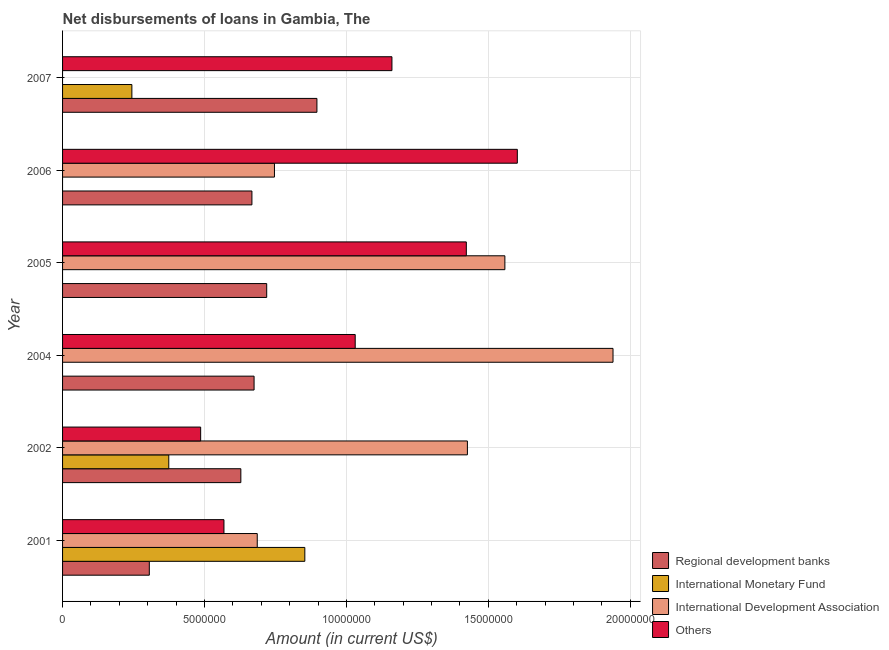How many different coloured bars are there?
Your response must be concise. 4. How many groups of bars are there?
Provide a short and direct response. 6. Are the number of bars per tick equal to the number of legend labels?
Make the answer very short. No. How many bars are there on the 5th tick from the bottom?
Your answer should be compact. 3. What is the label of the 2nd group of bars from the top?
Offer a very short reply. 2006. Across all years, what is the maximum amount of loan disimbursed by international monetary fund?
Make the answer very short. 8.54e+06. In which year was the amount of loan disimbursed by international development association maximum?
Make the answer very short. 2004. What is the total amount of loan disimbursed by international monetary fund in the graph?
Give a very brief answer. 1.47e+07. What is the difference between the amount of loan disimbursed by international development association in 2002 and that in 2004?
Offer a very short reply. -5.13e+06. What is the difference between the amount of loan disimbursed by international development association in 2002 and the amount of loan disimbursed by regional development banks in 2001?
Your response must be concise. 1.12e+07. What is the average amount of loan disimbursed by regional development banks per year?
Your answer should be compact. 6.48e+06. In the year 2004, what is the difference between the amount of loan disimbursed by regional development banks and amount of loan disimbursed by other organisations?
Provide a succinct answer. -3.56e+06. In how many years, is the amount of loan disimbursed by other organisations greater than 3000000 US$?
Your response must be concise. 6. What is the ratio of the amount of loan disimbursed by international monetary fund in 2002 to that in 2007?
Offer a terse response. 1.53. Is the amount of loan disimbursed by other organisations in 2002 less than that in 2006?
Provide a short and direct response. Yes. What is the difference between the highest and the second highest amount of loan disimbursed by regional development banks?
Your response must be concise. 1.77e+06. What is the difference between the highest and the lowest amount of loan disimbursed by regional development banks?
Offer a terse response. 5.90e+06. Is the sum of the amount of loan disimbursed by international monetary fund in 2001 and 2007 greater than the maximum amount of loan disimbursed by regional development banks across all years?
Your response must be concise. Yes. Are all the bars in the graph horizontal?
Ensure brevity in your answer.  Yes. How many years are there in the graph?
Your response must be concise. 6. What is the difference between two consecutive major ticks on the X-axis?
Your response must be concise. 5.00e+06. Does the graph contain any zero values?
Keep it short and to the point. Yes. Where does the legend appear in the graph?
Make the answer very short. Bottom right. How are the legend labels stacked?
Offer a very short reply. Vertical. What is the title of the graph?
Your answer should be compact. Net disbursements of loans in Gambia, The. Does "International Development Association" appear as one of the legend labels in the graph?
Ensure brevity in your answer.  Yes. What is the label or title of the Y-axis?
Provide a succinct answer. Year. What is the Amount (in current US$) in Regional development banks in 2001?
Offer a very short reply. 3.06e+06. What is the Amount (in current US$) in International Monetary Fund in 2001?
Provide a succinct answer. 8.54e+06. What is the Amount (in current US$) in International Development Association in 2001?
Your answer should be very brief. 6.86e+06. What is the Amount (in current US$) of Others in 2001?
Give a very brief answer. 5.69e+06. What is the Amount (in current US$) in Regional development banks in 2002?
Keep it short and to the point. 6.28e+06. What is the Amount (in current US$) of International Monetary Fund in 2002?
Offer a terse response. 3.74e+06. What is the Amount (in current US$) in International Development Association in 2002?
Give a very brief answer. 1.43e+07. What is the Amount (in current US$) of Others in 2002?
Your response must be concise. 4.86e+06. What is the Amount (in current US$) of Regional development banks in 2004?
Your answer should be very brief. 6.75e+06. What is the Amount (in current US$) in International Monetary Fund in 2004?
Provide a short and direct response. 0. What is the Amount (in current US$) of International Development Association in 2004?
Your answer should be compact. 1.94e+07. What is the Amount (in current US$) in Others in 2004?
Offer a terse response. 1.03e+07. What is the Amount (in current US$) in Regional development banks in 2005?
Give a very brief answer. 7.19e+06. What is the Amount (in current US$) in International Monetary Fund in 2005?
Your answer should be very brief. 0. What is the Amount (in current US$) of International Development Association in 2005?
Keep it short and to the point. 1.56e+07. What is the Amount (in current US$) of Others in 2005?
Your response must be concise. 1.42e+07. What is the Amount (in current US$) of Regional development banks in 2006?
Your answer should be very brief. 6.67e+06. What is the Amount (in current US$) in International Monetary Fund in 2006?
Make the answer very short. 0. What is the Amount (in current US$) in International Development Association in 2006?
Offer a very short reply. 7.46e+06. What is the Amount (in current US$) of Others in 2006?
Provide a succinct answer. 1.60e+07. What is the Amount (in current US$) of Regional development banks in 2007?
Your answer should be compact. 8.96e+06. What is the Amount (in current US$) of International Monetary Fund in 2007?
Make the answer very short. 2.44e+06. What is the Amount (in current US$) of Others in 2007?
Your answer should be very brief. 1.16e+07. Across all years, what is the maximum Amount (in current US$) in Regional development banks?
Your answer should be compact. 8.96e+06. Across all years, what is the maximum Amount (in current US$) of International Monetary Fund?
Offer a terse response. 8.54e+06. Across all years, what is the maximum Amount (in current US$) in International Development Association?
Your answer should be very brief. 1.94e+07. Across all years, what is the maximum Amount (in current US$) of Others?
Your answer should be very brief. 1.60e+07. Across all years, what is the minimum Amount (in current US$) of Regional development banks?
Offer a very short reply. 3.06e+06. Across all years, what is the minimum Amount (in current US$) of Others?
Ensure brevity in your answer.  4.86e+06. What is the total Amount (in current US$) of Regional development banks in the graph?
Provide a succinct answer. 3.89e+07. What is the total Amount (in current US$) in International Monetary Fund in the graph?
Ensure brevity in your answer.  1.47e+07. What is the total Amount (in current US$) of International Development Association in the graph?
Provide a succinct answer. 6.36e+07. What is the total Amount (in current US$) of Others in the graph?
Provide a short and direct response. 6.27e+07. What is the difference between the Amount (in current US$) in Regional development banks in 2001 and that in 2002?
Your response must be concise. -3.22e+06. What is the difference between the Amount (in current US$) in International Monetary Fund in 2001 and that in 2002?
Offer a terse response. 4.79e+06. What is the difference between the Amount (in current US$) in International Development Association in 2001 and that in 2002?
Ensure brevity in your answer.  -7.40e+06. What is the difference between the Amount (in current US$) of Others in 2001 and that in 2002?
Offer a very short reply. 8.21e+05. What is the difference between the Amount (in current US$) of Regional development banks in 2001 and that in 2004?
Ensure brevity in your answer.  -3.69e+06. What is the difference between the Amount (in current US$) of International Development Association in 2001 and that in 2004?
Provide a succinct answer. -1.25e+07. What is the difference between the Amount (in current US$) of Others in 2001 and that in 2004?
Your answer should be very brief. -4.62e+06. What is the difference between the Amount (in current US$) of Regional development banks in 2001 and that in 2005?
Offer a terse response. -4.14e+06. What is the difference between the Amount (in current US$) in International Development Association in 2001 and that in 2005?
Provide a succinct answer. -8.72e+06. What is the difference between the Amount (in current US$) in Others in 2001 and that in 2005?
Your answer should be compact. -8.54e+06. What is the difference between the Amount (in current US$) in Regional development banks in 2001 and that in 2006?
Offer a very short reply. -3.62e+06. What is the difference between the Amount (in current US$) of International Development Association in 2001 and that in 2006?
Offer a terse response. -6.06e+05. What is the difference between the Amount (in current US$) of Others in 2001 and that in 2006?
Ensure brevity in your answer.  -1.03e+07. What is the difference between the Amount (in current US$) of Regional development banks in 2001 and that in 2007?
Provide a short and direct response. -5.90e+06. What is the difference between the Amount (in current US$) in International Monetary Fund in 2001 and that in 2007?
Offer a very short reply. 6.09e+06. What is the difference between the Amount (in current US$) in Others in 2001 and that in 2007?
Offer a terse response. -5.92e+06. What is the difference between the Amount (in current US$) in Regional development banks in 2002 and that in 2004?
Provide a short and direct response. -4.66e+05. What is the difference between the Amount (in current US$) in International Development Association in 2002 and that in 2004?
Offer a terse response. -5.13e+06. What is the difference between the Amount (in current US$) of Others in 2002 and that in 2004?
Your response must be concise. -5.44e+06. What is the difference between the Amount (in current US$) of Regional development banks in 2002 and that in 2005?
Make the answer very short. -9.11e+05. What is the difference between the Amount (in current US$) in International Development Association in 2002 and that in 2005?
Your answer should be compact. -1.32e+06. What is the difference between the Amount (in current US$) of Others in 2002 and that in 2005?
Offer a very short reply. -9.36e+06. What is the difference between the Amount (in current US$) in Regional development banks in 2002 and that in 2006?
Provide a succinct answer. -3.90e+05. What is the difference between the Amount (in current US$) of International Development Association in 2002 and that in 2006?
Provide a short and direct response. 6.80e+06. What is the difference between the Amount (in current US$) of Others in 2002 and that in 2006?
Your response must be concise. -1.12e+07. What is the difference between the Amount (in current US$) of Regional development banks in 2002 and that in 2007?
Offer a very short reply. -2.68e+06. What is the difference between the Amount (in current US$) of International Monetary Fund in 2002 and that in 2007?
Offer a terse response. 1.30e+06. What is the difference between the Amount (in current US$) of Others in 2002 and that in 2007?
Make the answer very short. -6.74e+06. What is the difference between the Amount (in current US$) of Regional development banks in 2004 and that in 2005?
Your answer should be very brief. -4.45e+05. What is the difference between the Amount (in current US$) in International Development Association in 2004 and that in 2005?
Your answer should be very brief. 3.81e+06. What is the difference between the Amount (in current US$) in Others in 2004 and that in 2005?
Make the answer very short. -3.92e+06. What is the difference between the Amount (in current US$) of Regional development banks in 2004 and that in 2006?
Provide a short and direct response. 7.60e+04. What is the difference between the Amount (in current US$) in International Development Association in 2004 and that in 2006?
Offer a terse response. 1.19e+07. What is the difference between the Amount (in current US$) in Others in 2004 and that in 2006?
Offer a very short reply. -5.71e+06. What is the difference between the Amount (in current US$) in Regional development banks in 2004 and that in 2007?
Provide a short and direct response. -2.21e+06. What is the difference between the Amount (in current US$) of Others in 2004 and that in 2007?
Your answer should be compact. -1.29e+06. What is the difference between the Amount (in current US$) in Regional development banks in 2005 and that in 2006?
Offer a terse response. 5.21e+05. What is the difference between the Amount (in current US$) in International Development Association in 2005 and that in 2006?
Ensure brevity in your answer.  8.12e+06. What is the difference between the Amount (in current US$) in Others in 2005 and that in 2006?
Your answer should be compact. -1.80e+06. What is the difference between the Amount (in current US$) in Regional development banks in 2005 and that in 2007?
Make the answer very short. -1.77e+06. What is the difference between the Amount (in current US$) in Others in 2005 and that in 2007?
Offer a terse response. 2.62e+06. What is the difference between the Amount (in current US$) of Regional development banks in 2006 and that in 2007?
Make the answer very short. -2.29e+06. What is the difference between the Amount (in current US$) in Others in 2006 and that in 2007?
Your answer should be compact. 4.42e+06. What is the difference between the Amount (in current US$) in Regional development banks in 2001 and the Amount (in current US$) in International Monetary Fund in 2002?
Give a very brief answer. -6.86e+05. What is the difference between the Amount (in current US$) of Regional development banks in 2001 and the Amount (in current US$) of International Development Association in 2002?
Your response must be concise. -1.12e+07. What is the difference between the Amount (in current US$) in Regional development banks in 2001 and the Amount (in current US$) in Others in 2002?
Make the answer very short. -1.81e+06. What is the difference between the Amount (in current US$) in International Monetary Fund in 2001 and the Amount (in current US$) in International Development Association in 2002?
Your answer should be compact. -5.73e+06. What is the difference between the Amount (in current US$) of International Monetary Fund in 2001 and the Amount (in current US$) of Others in 2002?
Offer a very short reply. 3.67e+06. What is the difference between the Amount (in current US$) of International Development Association in 2001 and the Amount (in current US$) of Others in 2002?
Ensure brevity in your answer.  1.99e+06. What is the difference between the Amount (in current US$) of Regional development banks in 2001 and the Amount (in current US$) of International Development Association in 2004?
Ensure brevity in your answer.  -1.63e+07. What is the difference between the Amount (in current US$) of Regional development banks in 2001 and the Amount (in current US$) of Others in 2004?
Your response must be concise. -7.25e+06. What is the difference between the Amount (in current US$) of International Monetary Fund in 2001 and the Amount (in current US$) of International Development Association in 2004?
Offer a very short reply. -1.09e+07. What is the difference between the Amount (in current US$) of International Monetary Fund in 2001 and the Amount (in current US$) of Others in 2004?
Provide a short and direct response. -1.78e+06. What is the difference between the Amount (in current US$) in International Development Association in 2001 and the Amount (in current US$) in Others in 2004?
Offer a very short reply. -3.45e+06. What is the difference between the Amount (in current US$) in Regional development banks in 2001 and the Amount (in current US$) in International Development Association in 2005?
Provide a succinct answer. -1.25e+07. What is the difference between the Amount (in current US$) of Regional development banks in 2001 and the Amount (in current US$) of Others in 2005?
Provide a succinct answer. -1.12e+07. What is the difference between the Amount (in current US$) of International Monetary Fund in 2001 and the Amount (in current US$) of International Development Association in 2005?
Your response must be concise. -7.05e+06. What is the difference between the Amount (in current US$) of International Monetary Fund in 2001 and the Amount (in current US$) of Others in 2005?
Provide a succinct answer. -5.69e+06. What is the difference between the Amount (in current US$) of International Development Association in 2001 and the Amount (in current US$) of Others in 2005?
Provide a short and direct response. -7.37e+06. What is the difference between the Amount (in current US$) of Regional development banks in 2001 and the Amount (in current US$) of International Development Association in 2006?
Provide a short and direct response. -4.41e+06. What is the difference between the Amount (in current US$) of Regional development banks in 2001 and the Amount (in current US$) of Others in 2006?
Provide a succinct answer. -1.30e+07. What is the difference between the Amount (in current US$) in International Monetary Fund in 2001 and the Amount (in current US$) in International Development Association in 2006?
Offer a terse response. 1.07e+06. What is the difference between the Amount (in current US$) of International Monetary Fund in 2001 and the Amount (in current US$) of Others in 2006?
Keep it short and to the point. -7.49e+06. What is the difference between the Amount (in current US$) of International Development Association in 2001 and the Amount (in current US$) of Others in 2006?
Your response must be concise. -9.16e+06. What is the difference between the Amount (in current US$) of Regional development banks in 2001 and the Amount (in current US$) of International Monetary Fund in 2007?
Offer a very short reply. 6.14e+05. What is the difference between the Amount (in current US$) of Regional development banks in 2001 and the Amount (in current US$) of Others in 2007?
Provide a succinct answer. -8.55e+06. What is the difference between the Amount (in current US$) of International Monetary Fund in 2001 and the Amount (in current US$) of Others in 2007?
Give a very brief answer. -3.07e+06. What is the difference between the Amount (in current US$) in International Development Association in 2001 and the Amount (in current US$) in Others in 2007?
Your response must be concise. -4.74e+06. What is the difference between the Amount (in current US$) of Regional development banks in 2002 and the Amount (in current US$) of International Development Association in 2004?
Provide a succinct answer. -1.31e+07. What is the difference between the Amount (in current US$) of Regional development banks in 2002 and the Amount (in current US$) of Others in 2004?
Provide a succinct answer. -4.03e+06. What is the difference between the Amount (in current US$) in International Monetary Fund in 2002 and the Amount (in current US$) in International Development Association in 2004?
Your answer should be compact. -1.57e+07. What is the difference between the Amount (in current US$) in International Monetary Fund in 2002 and the Amount (in current US$) in Others in 2004?
Ensure brevity in your answer.  -6.57e+06. What is the difference between the Amount (in current US$) in International Development Association in 2002 and the Amount (in current US$) in Others in 2004?
Keep it short and to the point. 3.95e+06. What is the difference between the Amount (in current US$) of Regional development banks in 2002 and the Amount (in current US$) of International Development Association in 2005?
Offer a very short reply. -9.30e+06. What is the difference between the Amount (in current US$) of Regional development banks in 2002 and the Amount (in current US$) of Others in 2005?
Ensure brevity in your answer.  -7.94e+06. What is the difference between the Amount (in current US$) of International Monetary Fund in 2002 and the Amount (in current US$) of International Development Association in 2005?
Your answer should be compact. -1.18e+07. What is the difference between the Amount (in current US$) in International Monetary Fund in 2002 and the Amount (in current US$) in Others in 2005?
Offer a terse response. -1.05e+07. What is the difference between the Amount (in current US$) in International Development Association in 2002 and the Amount (in current US$) in Others in 2005?
Offer a terse response. 3.80e+04. What is the difference between the Amount (in current US$) in Regional development banks in 2002 and the Amount (in current US$) in International Development Association in 2006?
Ensure brevity in your answer.  -1.18e+06. What is the difference between the Amount (in current US$) of Regional development banks in 2002 and the Amount (in current US$) of Others in 2006?
Provide a succinct answer. -9.74e+06. What is the difference between the Amount (in current US$) in International Monetary Fund in 2002 and the Amount (in current US$) in International Development Association in 2006?
Provide a short and direct response. -3.72e+06. What is the difference between the Amount (in current US$) in International Monetary Fund in 2002 and the Amount (in current US$) in Others in 2006?
Offer a very short reply. -1.23e+07. What is the difference between the Amount (in current US$) of International Development Association in 2002 and the Amount (in current US$) of Others in 2006?
Make the answer very short. -1.76e+06. What is the difference between the Amount (in current US$) in Regional development banks in 2002 and the Amount (in current US$) in International Monetary Fund in 2007?
Your answer should be compact. 3.84e+06. What is the difference between the Amount (in current US$) of Regional development banks in 2002 and the Amount (in current US$) of Others in 2007?
Offer a terse response. -5.32e+06. What is the difference between the Amount (in current US$) of International Monetary Fund in 2002 and the Amount (in current US$) of Others in 2007?
Keep it short and to the point. -7.86e+06. What is the difference between the Amount (in current US$) in International Development Association in 2002 and the Amount (in current US$) in Others in 2007?
Your answer should be compact. 2.66e+06. What is the difference between the Amount (in current US$) in Regional development banks in 2004 and the Amount (in current US$) in International Development Association in 2005?
Give a very brief answer. -8.84e+06. What is the difference between the Amount (in current US$) in Regional development banks in 2004 and the Amount (in current US$) in Others in 2005?
Your response must be concise. -7.48e+06. What is the difference between the Amount (in current US$) in International Development Association in 2004 and the Amount (in current US$) in Others in 2005?
Your answer should be very brief. 5.17e+06. What is the difference between the Amount (in current US$) in Regional development banks in 2004 and the Amount (in current US$) in International Development Association in 2006?
Provide a short and direct response. -7.18e+05. What is the difference between the Amount (in current US$) of Regional development banks in 2004 and the Amount (in current US$) of Others in 2006?
Provide a short and direct response. -9.28e+06. What is the difference between the Amount (in current US$) in International Development Association in 2004 and the Amount (in current US$) in Others in 2006?
Offer a terse response. 3.37e+06. What is the difference between the Amount (in current US$) of Regional development banks in 2004 and the Amount (in current US$) of International Monetary Fund in 2007?
Your answer should be compact. 4.30e+06. What is the difference between the Amount (in current US$) in Regional development banks in 2004 and the Amount (in current US$) in Others in 2007?
Keep it short and to the point. -4.86e+06. What is the difference between the Amount (in current US$) of International Development Association in 2004 and the Amount (in current US$) of Others in 2007?
Your answer should be very brief. 7.79e+06. What is the difference between the Amount (in current US$) of Regional development banks in 2005 and the Amount (in current US$) of International Development Association in 2006?
Offer a terse response. -2.73e+05. What is the difference between the Amount (in current US$) in Regional development banks in 2005 and the Amount (in current US$) in Others in 2006?
Provide a short and direct response. -8.83e+06. What is the difference between the Amount (in current US$) in International Development Association in 2005 and the Amount (in current US$) in Others in 2006?
Make the answer very short. -4.39e+05. What is the difference between the Amount (in current US$) of Regional development banks in 2005 and the Amount (in current US$) of International Monetary Fund in 2007?
Give a very brief answer. 4.75e+06. What is the difference between the Amount (in current US$) in Regional development banks in 2005 and the Amount (in current US$) in Others in 2007?
Your response must be concise. -4.41e+06. What is the difference between the Amount (in current US$) of International Development Association in 2005 and the Amount (in current US$) of Others in 2007?
Make the answer very short. 3.98e+06. What is the difference between the Amount (in current US$) in Regional development banks in 2006 and the Amount (in current US$) in International Monetary Fund in 2007?
Offer a terse response. 4.23e+06. What is the difference between the Amount (in current US$) in Regional development banks in 2006 and the Amount (in current US$) in Others in 2007?
Provide a succinct answer. -4.93e+06. What is the difference between the Amount (in current US$) of International Development Association in 2006 and the Amount (in current US$) of Others in 2007?
Provide a succinct answer. -4.14e+06. What is the average Amount (in current US$) in Regional development banks per year?
Your answer should be very brief. 6.48e+06. What is the average Amount (in current US$) of International Monetary Fund per year?
Provide a short and direct response. 2.45e+06. What is the average Amount (in current US$) of International Development Association per year?
Your response must be concise. 1.06e+07. What is the average Amount (in current US$) in Others per year?
Your answer should be compact. 1.05e+07. In the year 2001, what is the difference between the Amount (in current US$) in Regional development banks and Amount (in current US$) in International Monetary Fund?
Offer a very short reply. -5.48e+06. In the year 2001, what is the difference between the Amount (in current US$) in Regional development banks and Amount (in current US$) in International Development Association?
Your answer should be very brief. -3.80e+06. In the year 2001, what is the difference between the Amount (in current US$) of Regional development banks and Amount (in current US$) of Others?
Give a very brief answer. -2.63e+06. In the year 2001, what is the difference between the Amount (in current US$) in International Monetary Fund and Amount (in current US$) in International Development Association?
Provide a short and direct response. 1.68e+06. In the year 2001, what is the difference between the Amount (in current US$) in International Monetary Fund and Amount (in current US$) in Others?
Offer a terse response. 2.85e+06. In the year 2001, what is the difference between the Amount (in current US$) of International Development Association and Amount (in current US$) of Others?
Your answer should be very brief. 1.17e+06. In the year 2002, what is the difference between the Amount (in current US$) in Regional development banks and Amount (in current US$) in International Monetary Fund?
Make the answer very short. 2.54e+06. In the year 2002, what is the difference between the Amount (in current US$) of Regional development banks and Amount (in current US$) of International Development Association?
Your answer should be compact. -7.98e+06. In the year 2002, what is the difference between the Amount (in current US$) in Regional development banks and Amount (in current US$) in Others?
Provide a short and direct response. 1.42e+06. In the year 2002, what is the difference between the Amount (in current US$) in International Monetary Fund and Amount (in current US$) in International Development Association?
Provide a succinct answer. -1.05e+07. In the year 2002, what is the difference between the Amount (in current US$) in International Monetary Fund and Amount (in current US$) in Others?
Ensure brevity in your answer.  -1.12e+06. In the year 2002, what is the difference between the Amount (in current US$) of International Development Association and Amount (in current US$) of Others?
Ensure brevity in your answer.  9.40e+06. In the year 2004, what is the difference between the Amount (in current US$) in Regional development banks and Amount (in current US$) in International Development Association?
Provide a succinct answer. -1.26e+07. In the year 2004, what is the difference between the Amount (in current US$) in Regional development banks and Amount (in current US$) in Others?
Your response must be concise. -3.56e+06. In the year 2004, what is the difference between the Amount (in current US$) in International Development Association and Amount (in current US$) in Others?
Provide a short and direct response. 9.08e+06. In the year 2005, what is the difference between the Amount (in current US$) in Regional development banks and Amount (in current US$) in International Development Association?
Offer a terse response. -8.39e+06. In the year 2005, what is the difference between the Amount (in current US$) of Regional development banks and Amount (in current US$) of Others?
Your answer should be compact. -7.03e+06. In the year 2005, what is the difference between the Amount (in current US$) of International Development Association and Amount (in current US$) of Others?
Provide a succinct answer. 1.36e+06. In the year 2006, what is the difference between the Amount (in current US$) of Regional development banks and Amount (in current US$) of International Development Association?
Offer a terse response. -7.94e+05. In the year 2006, what is the difference between the Amount (in current US$) in Regional development banks and Amount (in current US$) in Others?
Offer a terse response. -9.35e+06. In the year 2006, what is the difference between the Amount (in current US$) in International Development Association and Amount (in current US$) in Others?
Make the answer very short. -8.56e+06. In the year 2007, what is the difference between the Amount (in current US$) in Regional development banks and Amount (in current US$) in International Monetary Fund?
Give a very brief answer. 6.52e+06. In the year 2007, what is the difference between the Amount (in current US$) of Regional development banks and Amount (in current US$) of Others?
Give a very brief answer. -2.64e+06. In the year 2007, what is the difference between the Amount (in current US$) in International Monetary Fund and Amount (in current US$) in Others?
Offer a terse response. -9.16e+06. What is the ratio of the Amount (in current US$) in Regional development banks in 2001 to that in 2002?
Your response must be concise. 0.49. What is the ratio of the Amount (in current US$) in International Monetary Fund in 2001 to that in 2002?
Make the answer very short. 2.28. What is the ratio of the Amount (in current US$) in International Development Association in 2001 to that in 2002?
Provide a short and direct response. 0.48. What is the ratio of the Amount (in current US$) of Others in 2001 to that in 2002?
Your response must be concise. 1.17. What is the ratio of the Amount (in current US$) in Regional development banks in 2001 to that in 2004?
Make the answer very short. 0.45. What is the ratio of the Amount (in current US$) of International Development Association in 2001 to that in 2004?
Offer a terse response. 0.35. What is the ratio of the Amount (in current US$) in Others in 2001 to that in 2004?
Ensure brevity in your answer.  0.55. What is the ratio of the Amount (in current US$) in Regional development banks in 2001 to that in 2005?
Provide a succinct answer. 0.42. What is the ratio of the Amount (in current US$) in International Development Association in 2001 to that in 2005?
Your response must be concise. 0.44. What is the ratio of the Amount (in current US$) of Others in 2001 to that in 2005?
Give a very brief answer. 0.4. What is the ratio of the Amount (in current US$) in Regional development banks in 2001 to that in 2006?
Give a very brief answer. 0.46. What is the ratio of the Amount (in current US$) of International Development Association in 2001 to that in 2006?
Offer a terse response. 0.92. What is the ratio of the Amount (in current US$) of Others in 2001 to that in 2006?
Your answer should be compact. 0.35. What is the ratio of the Amount (in current US$) of Regional development banks in 2001 to that in 2007?
Your answer should be compact. 0.34. What is the ratio of the Amount (in current US$) in International Monetary Fund in 2001 to that in 2007?
Give a very brief answer. 3.5. What is the ratio of the Amount (in current US$) of Others in 2001 to that in 2007?
Your response must be concise. 0.49. What is the ratio of the Amount (in current US$) in Regional development banks in 2002 to that in 2004?
Offer a terse response. 0.93. What is the ratio of the Amount (in current US$) of International Development Association in 2002 to that in 2004?
Offer a terse response. 0.74. What is the ratio of the Amount (in current US$) of Others in 2002 to that in 2004?
Your answer should be compact. 0.47. What is the ratio of the Amount (in current US$) of Regional development banks in 2002 to that in 2005?
Ensure brevity in your answer.  0.87. What is the ratio of the Amount (in current US$) of International Development Association in 2002 to that in 2005?
Your response must be concise. 0.92. What is the ratio of the Amount (in current US$) in Others in 2002 to that in 2005?
Provide a succinct answer. 0.34. What is the ratio of the Amount (in current US$) of Regional development banks in 2002 to that in 2006?
Give a very brief answer. 0.94. What is the ratio of the Amount (in current US$) in International Development Association in 2002 to that in 2006?
Offer a very short reply. 1.91. What is the ratio of the Amount (in current US$) in Others in 2002 to that in 2006?
Ensure brevity in your answer.  0.3. What is the ratio of the Amount (in current US$) of Regional development banks in 2002 to that in 2007?
Provide a short and direct response. 0.7. What is the ratio of the Amount (in current US$) in International Monetary Fund in 2002 to that in 2007?
Offer a very short reply. 1.53. What is the ratio of the Amount (in current US$) in Others in 2002 to that in 2007?
Your answer should be compact. 0.42. What is the ratio of the Amount (in current US$) in Regional development banks in 2004 to that in 2005?
Ensure brevity in your answer.  0.94. What is the ratio of the Amount (in current US$) in International Development Association in 2004 to that in 2005?
Keep it short and to the point. 1.24. What is the ratio of the Amount (in current US$) of Others in 2004 to that in 2005?
Provide a short and direct response. 0.72. What is the ratio of the Amount (in current US$) in Regional development banks in 2004 to that in 2006?
Ensure brevity in your answer.  1.01. What is the ratio of the Amount (in current US$) in International Development Association in 2004 to that in 2006?
Give a very brief answer. 2.6. What is the ratio of the Amount (in current US$) in Others in 2004 to that in 2006?
Make the answer very short. 0.64. What is the ratio of the Amount (in current US$) of Regional development banks in 2004 to that in 2007?
Keep it short and to the point. 0.75. What is the ratio of the Amount (in current US$) of Others in 2004 to that in 2007?
Offer a very short reply. 0.89. What is the ratio of the Amount (in current US$) of Regional development banks in 2005 to that in 2006?
Provide a short and direct response. 1.08. What is the ratio of the Amount (in current US$) of International Development Association in 2005 to that in 2006?
Give a very brief answer. 2.09. What is the ratio of the Amount (in current US$) of Others in 2005 to that in 2006?
Give a very brief answer. 0.89. What is the ratio of the Amount (in current US$) of Regional development banks in 2005 to that in 2007?
Ensure brevity in your answer.  0.8. What is the ratio of the Amount (in current US$) of Others in 2005 to that in 2007?
Provide a short and direct response. 1.23. What is the ratio of the Amount (in current US$) of Regional development banks in 2006 to that in 2007?
Give a very brief answer. 0.74. What is the ratio of the Amount (in current US$) in Others in 2006 to that in 2007?
Provide a succinct answer. 1.38. What is the difference between the highest and the second highest Amount (in current US$) of Regional development banks?
Offer a very short reply. 1.77e+06. What is the difference between the highest and the second highest Amount (in current US$) in International Monetary Fund?
Give a very brief answer. 4.79e+06. What is the difference between the highest and the second highest Amount (in current US$) in International Development Association?
Ensure brevity in your answer.  3.81e+06. What is the difference between the highest and the second highest Amount (in current US$) in Others?
Offer a very short reply. 1.80e+06. What is the difference between the highest and the lowest Amount (in current US$) in Regional development banks?
Give a very brief answer. 5.90e+06. What is the difference between the highest and the lowest Amount (in current US$) in International Monetary Fund?
Provide a succinct answer. 8.54e+06. What is the difference between the highest and the lowest Amount (in current US$) of International Development Association?
Your answer should be compact. 1.94e+07. What is the difference between the highest and the lowest Amount (in current US$) of Others?
Offer a terse response. 1.12e+07. 